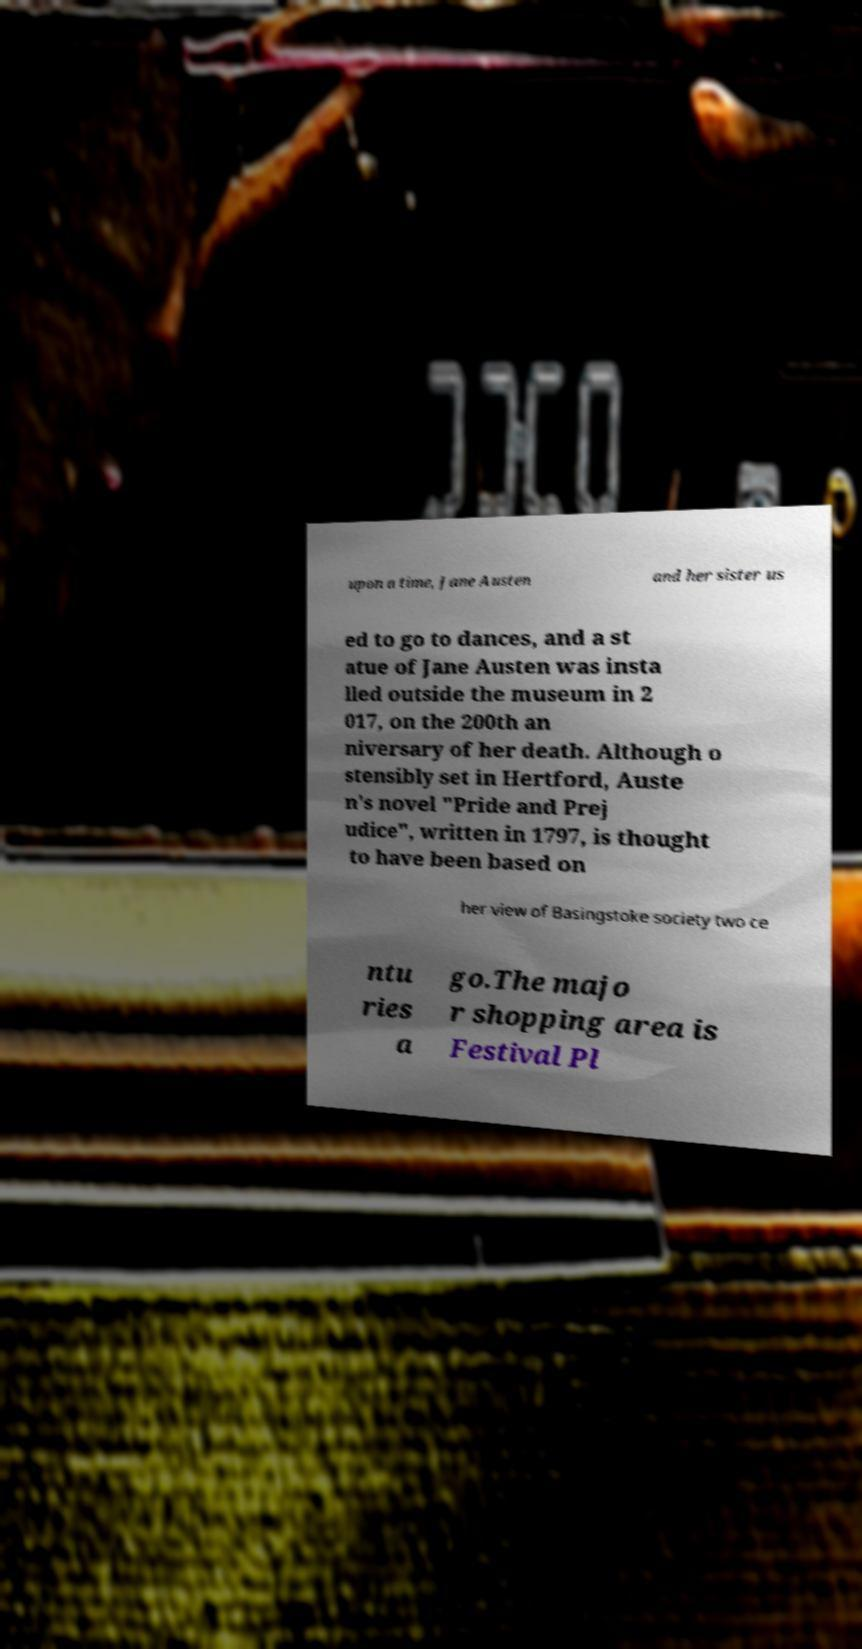Please identify and transcribe the text found in this image. upon a time, Jane Austen and her sister us ed to go to dances, and a st atue of Jane Austen was insta lled outside the museum in 2 017, on the 200th an niversary of her death. Although o stensibly set in Hertford, Auste n's novel "Pride and Prej udice", written in 1797, is thought to have been based on her view of Basingstoke society two ce ntu ries a go.The majo r shopping area is Festival Pl 